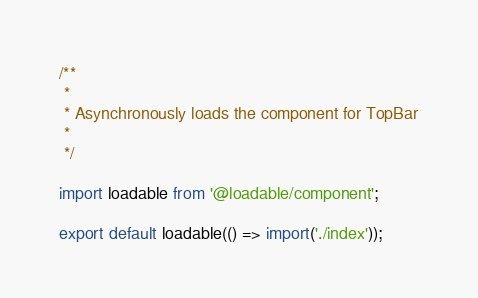Convert code to text. <code><loc_0><loc_0><loc_500><loc_500><_JavaScript_>/**
 *
 * Asynchronously loads the component for TopBar
 *
 */

import loadable from '@loadable/component';

export default loadable(() => import('./index'));
</code> 